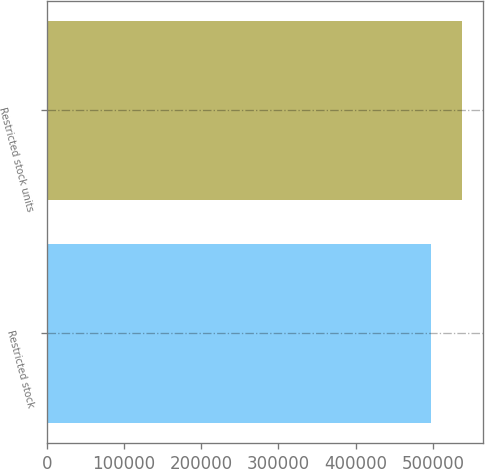<chart> <loc_0><loc_0><loc_500><loc_500><bar_chart><fcel>Restricted stock<fcel>Restricted stock units<nl><fcel>497100<fcel>537955<nl></chart> 